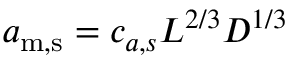Convert formula to latex. <formula><loc_0><loc_0><loc_500><loc_500>a _ { m , s } = c _ { a , s } L ^ { 2 / 3 } D ^ { 1 / 3 }</formula> 